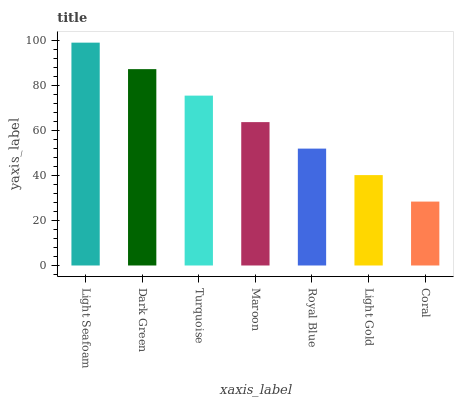Is Coral the minimum?
Answer yes or no. Yes. Is Light Seafoam the maximum?
Answer yes or no. Yes. Is Dark Green the minimum?
Answer yes or no. No. Is Dark Green the maximum?
Answer yes or no. No. Is Light Seafoam greater than Dark Green?
Answer yes or no. Yes. Is Dark Green less than Light Seafoam?
Answer yes or no. Yes. Is Dark Green greater than Light Seafoam?
Answer yes or no. No. Is Light Seafoam less than Dark Green?
Answer yes or no. No. Is Maroon the high median?
Answer yes or no. Yes. Is Maroon the low median?
Answer yes or no. Yes. Is Turquoise the high median?
Answer yes or no. No. Is Dark Green the low median?
Answer yes or no. No. 